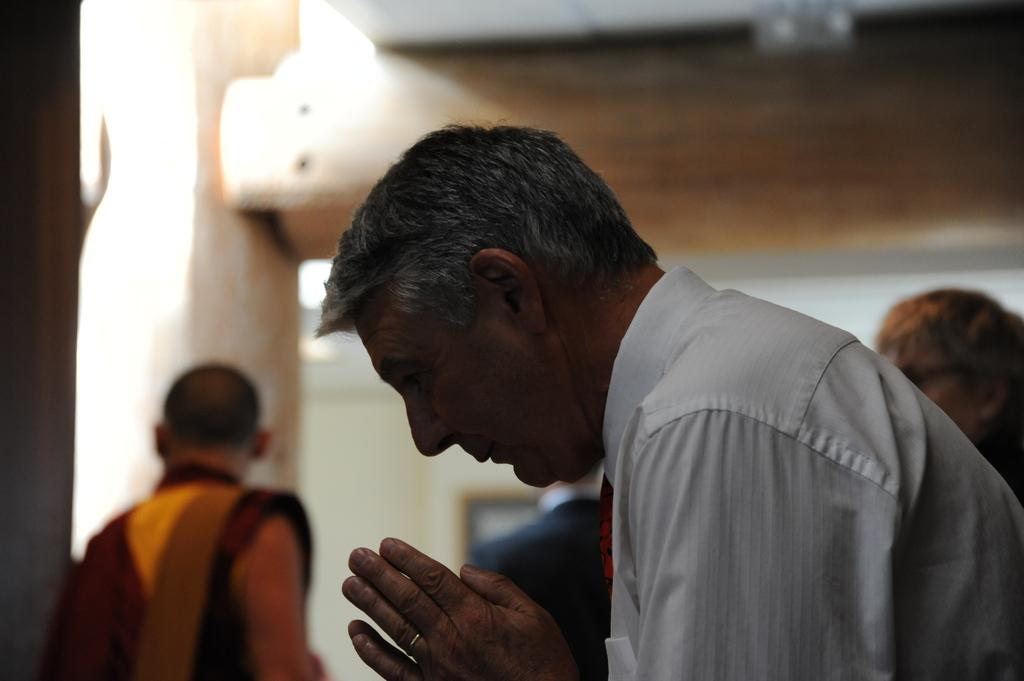What can be observed about the person in the image? There is a person wearing clothes in the image. How would you describe the background of the image? The background of the image is blurred. Can you identify any other people in the image? Yes, there is another person in the bottom left of the image. What type of holiday is being celebrated in the image? There is no indication of a holiday being celebrated in the image. How much sugar is present in the image? There is no sugar visible in the image. 